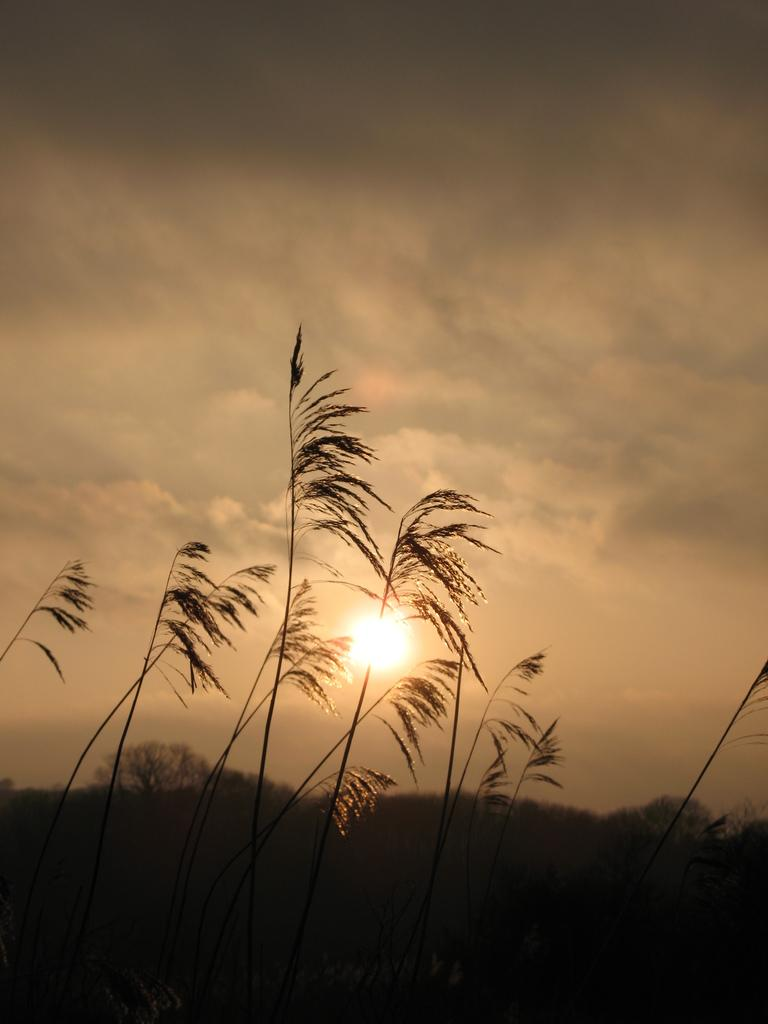What type of vegetation is present in the image? There is grass in the image. Are there any other natural elements in the image? Yes, there are trees in the image. What can be seen in the sky in the image? The sun is visible in the image. How would you describe the weather based on the sky in the image? The sky is cloudy in the image. Where is the cork located in the image? There is no cork present in the image. Can you see a square-shaped object in the image? There is no square-shaped object present in the image. 